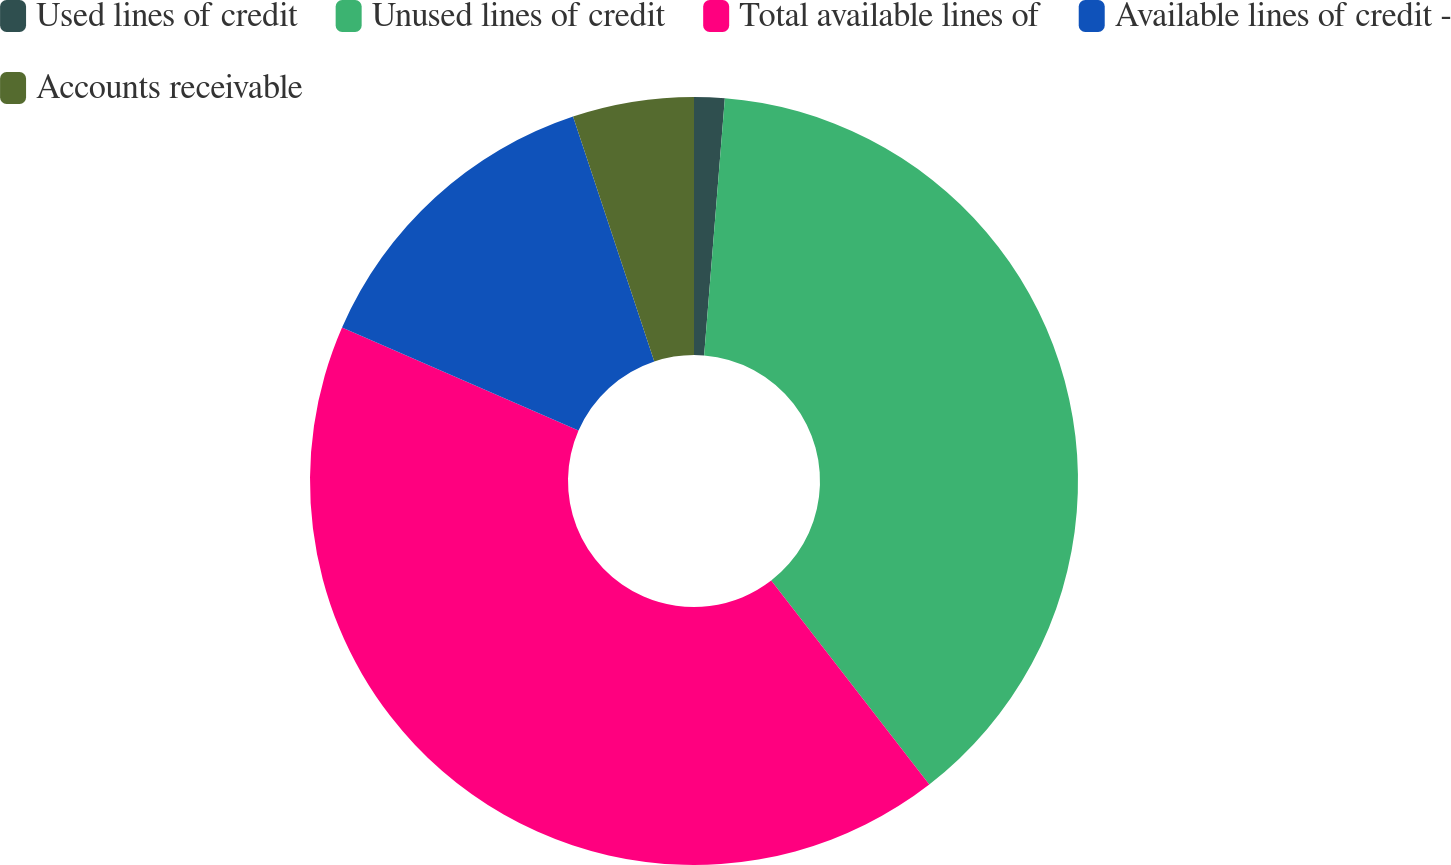<chart> <loc_0><loc_0><loc_500><loc_500><pie_chart><fcel>Used lines of credit<fcel>Unused lines of credit<fcel>Total available lines of<fcel>Available lines of credit -<fcel>Accounts receivable<nl><fcel>1.28%<fcel>38.22%<fcel>42.04%<fcel>13.35%<fcel>5.1%<nl></chart> 